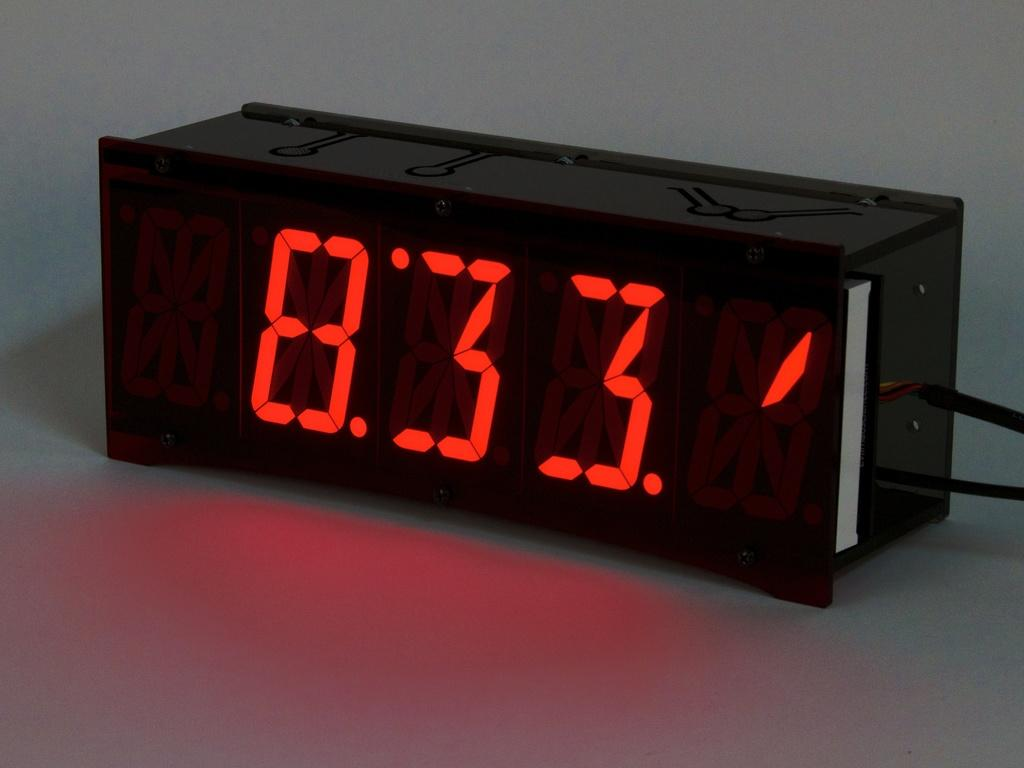<image>
Offer a succinct explanation of the picture presented. a digital clock on a counter with red numbers that read : '8:33' 